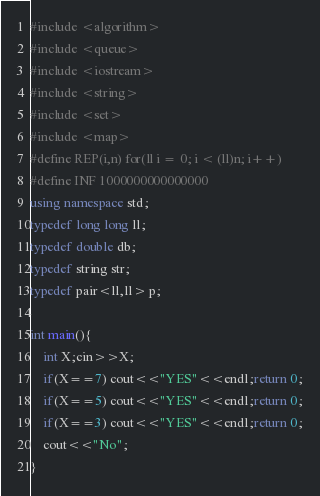Convert code to text. <code><loc_0><loc_0><loc_500><loc_500><_C++_>#include <algorithm>
#include <queue>
#include <iostream>
#include <string>
#include <set>
#include <map>
#define REP(i,n) for(ll i = 0; i < (ll)n; i++)
#define INF 1000000000000000
using namespace std;
typedef long long ll;
typedef double db;
typedef string str;
typedef pair<ll,ll> p;

int main(){
    int X;cin>>X;
    if(X==7) cout<<"YES"<<endl;return 0;
    if(X==5) cout<<"YES"<<endl;return 0;
    if(X==3) cout<<"YES"<<endl;return 0;
    cout<<"No";
}</code> 